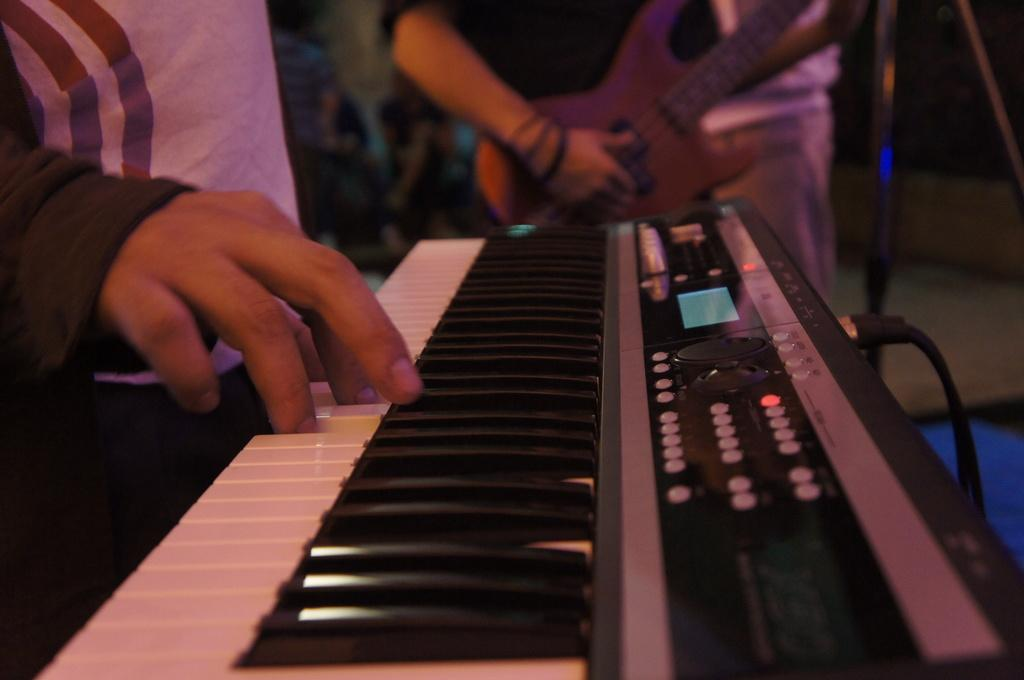Who is the main subject in the image? There is a person in the image. What is the person doing in the image? The person is playing a casio. What type of picture is hanging on the wall behind the person in the image? There is no information about a picture hanging on the wall behind the person in the image. How many ants can be seen crawling on the casio in the image? There are no ants present in the image. 